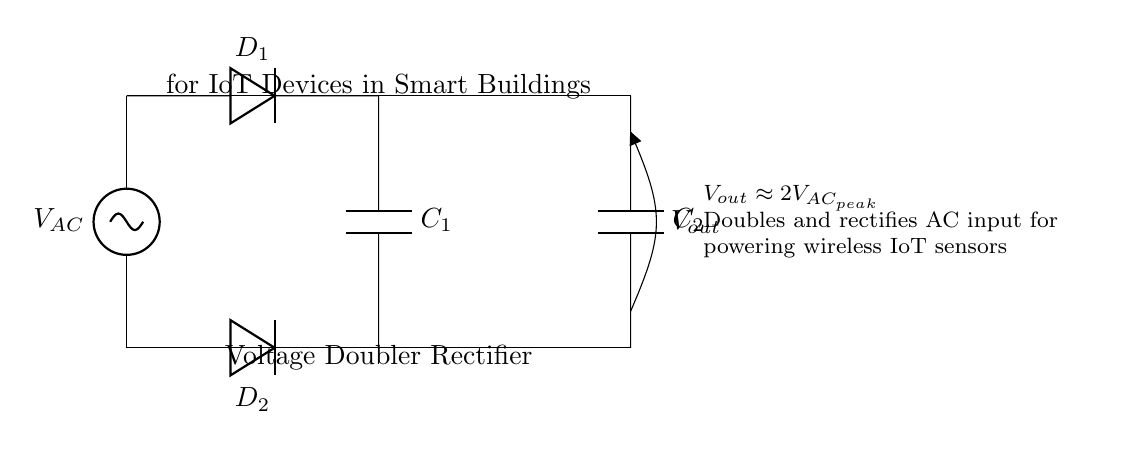What is the function of diode D1? Diode D1 conducts during the positive half-cycle of the AC input voltage, allowing current to flow toward C1 and charging it.
Answer: Conduct What is the output voltage of the circuit? The output voltage \(V_{out}\) will be approximately twice the peak input AC voltage, as the voltage doubler configuration doubles the output after rectification.
Answer: Two times peak AC What is the purpose of capacitor C1? Capacitor C1 serves to store charge during the positive half-cycle of the AC signal and smooth the rectified output.
Answer: To store charge How many capacitors are in this circuit? There are two capacitors (C1 and C2) present in the circuit, both essential for voltage doubling and smoothing the rectified output.
Answer: Two capacitors What happens during the negative half-cycle of the AC input? During the negative half-cycle, diode D2 conducts, allowing current to flow to capacitor C2 while diode D1 is reverse-biased and does not conduct, enabling the voltage doubling effect.
Answer: Diode D2 conducts How does this circuit improve power delivery for IoT devices? The voltage doubler rectifier circuit converts AC voltage to a higher DC voltage, which is typically needed for powering wireless IoT devices that require a steady and sufficient supply.
Answer: Converts AC to higher DC 